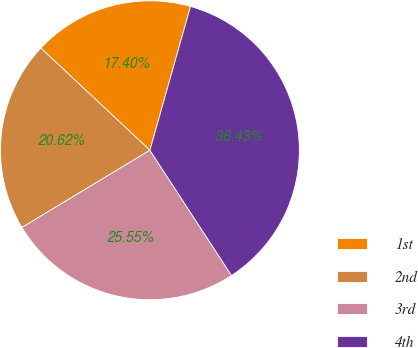Convert chart. <chart><loc_0><loc_0><loc_500><loc_500><pie_chart><fcel>1st<fcel>2nd<fcel>3rd<fcel>4th<nl><fcel>17.4%<fcel>20.62%<fcel>25.55%<fcel>36.43%<nl></chart> 